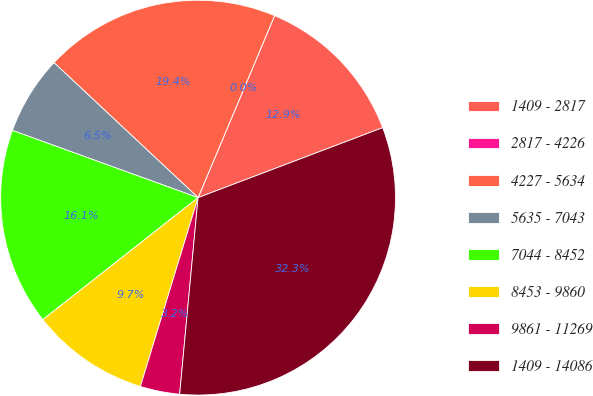Convert chart to OTSL. <chart><loc_0><loc_0><loc_500><loc_500><pie_chart><fcel>1409 - 2817<fcel>2817 - 4226<fcel>4227 - 5634<fcel>5635 - 7043<fcel>7044 - 8452<fcel>8453 - 9860<fcel>9861 - 11269<fcel>1409 - 14086<nl><fcel>12.9%<fcel>0.0%<fcel>19.35%<fcel>6.45%<fcel>16.13%<fcel>9.68%<fcel>3.23%<fcel>32.25%<nl></chart> 